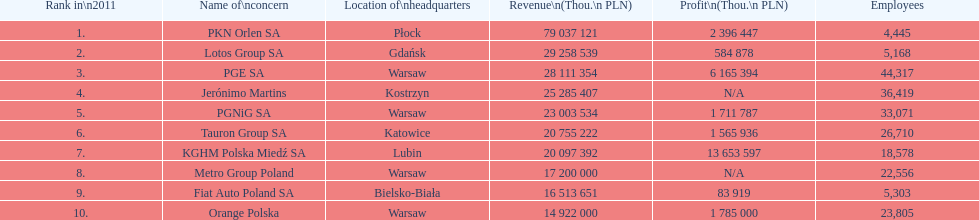Which company had the most revenue? PKN Orlen SA. 